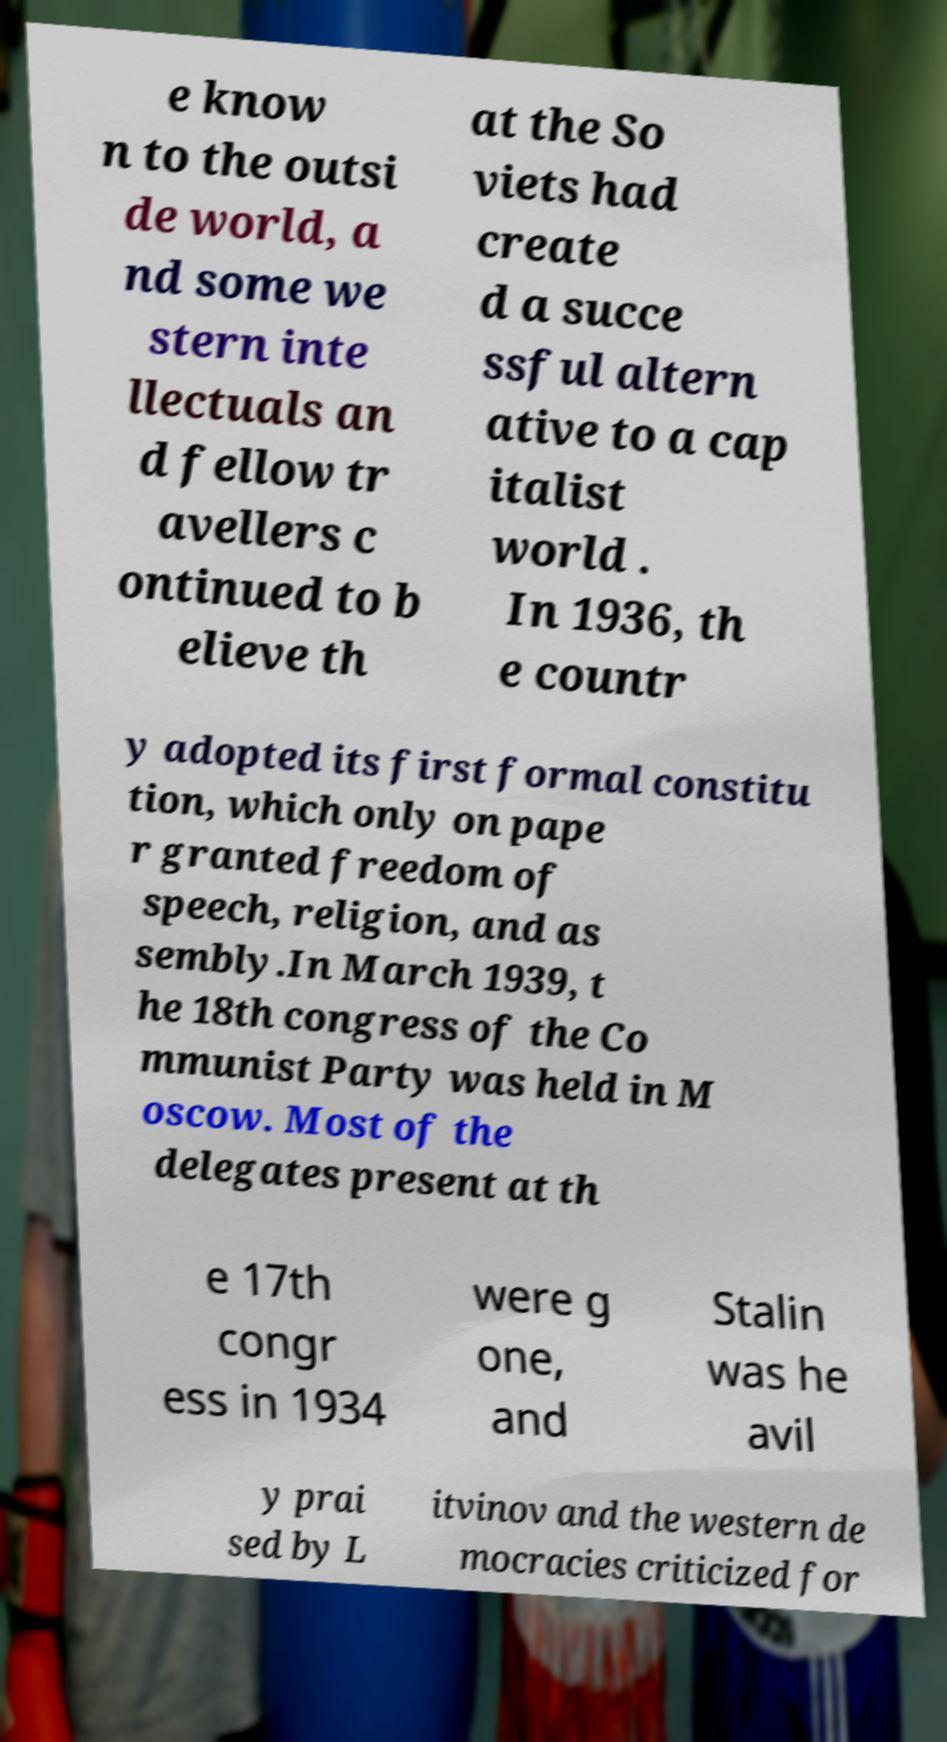Please identify and transcribe the text found in this image. e know n to the outsi de world, a nd some we stern inte llectuals an d fellow tr avellers c ontinued to b elieve th at the So viets had create d a succe ssful altern ative to a cap italist world . In 1936, th e countr y adopted its first formal constitu tion, which only on pape r granted freedom of speech, religion, and as sembly.In March 1939, t he 18th congress of the Co mmunist Party was held in M oscow. Most of the delegates present at th e 17th congr ess in 1934 were g one, and Stalin was he avil y prai sed by L itvinov and the western de mocracies criticized for 